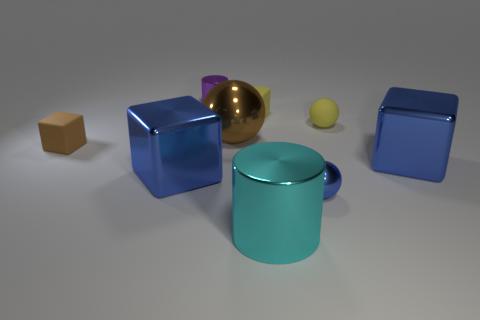What is the relation between the size of the objects and the distance from the viewer in this image? The objects vary in size, which creates a sense of depth in the image. Objects that are larger appear to be closer to the viewer, while smaller objects appear to be further away. This is known as forced perspective, a visual effect that can make an image more interesting. 